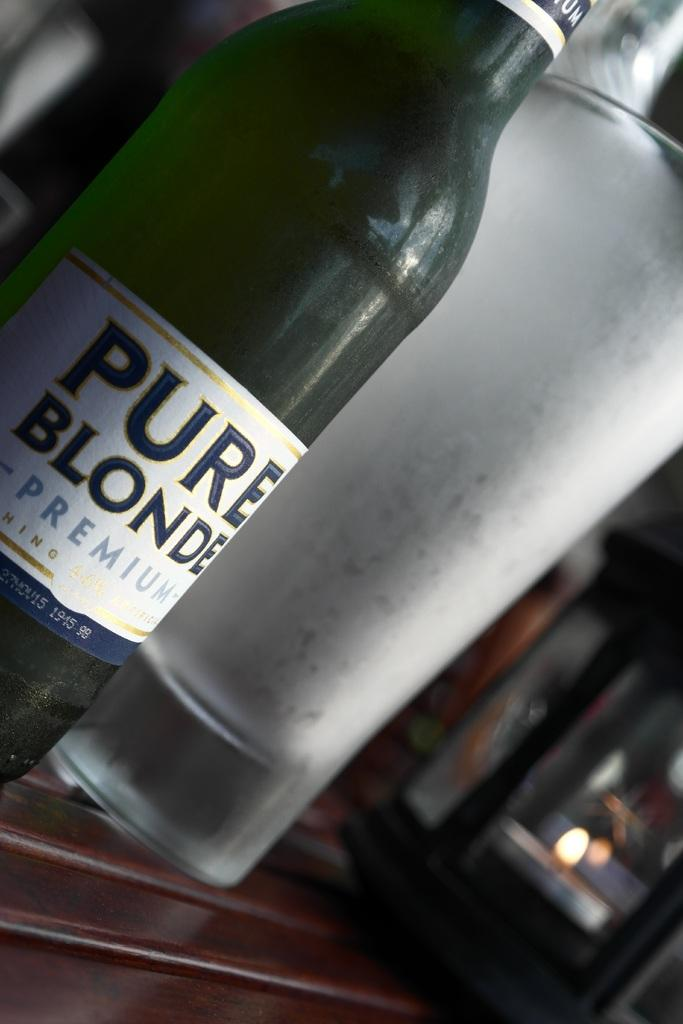<image>
Relay a brief, clear account of the picture shown. Bottle of Pure Blonde Premium beer next to a chilled pint glass. 